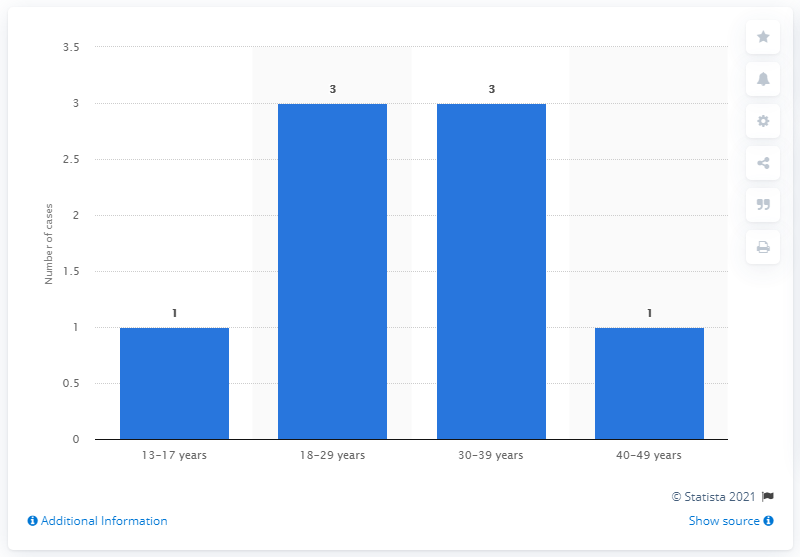Draw attention to some important aspects in this diagram. Data shows that out of the total number of active COVID-19 infections, cases from the 13-17 and 18-29 age groups represent 50% of the total. The longer bars have a greater value than the shorter bars. 